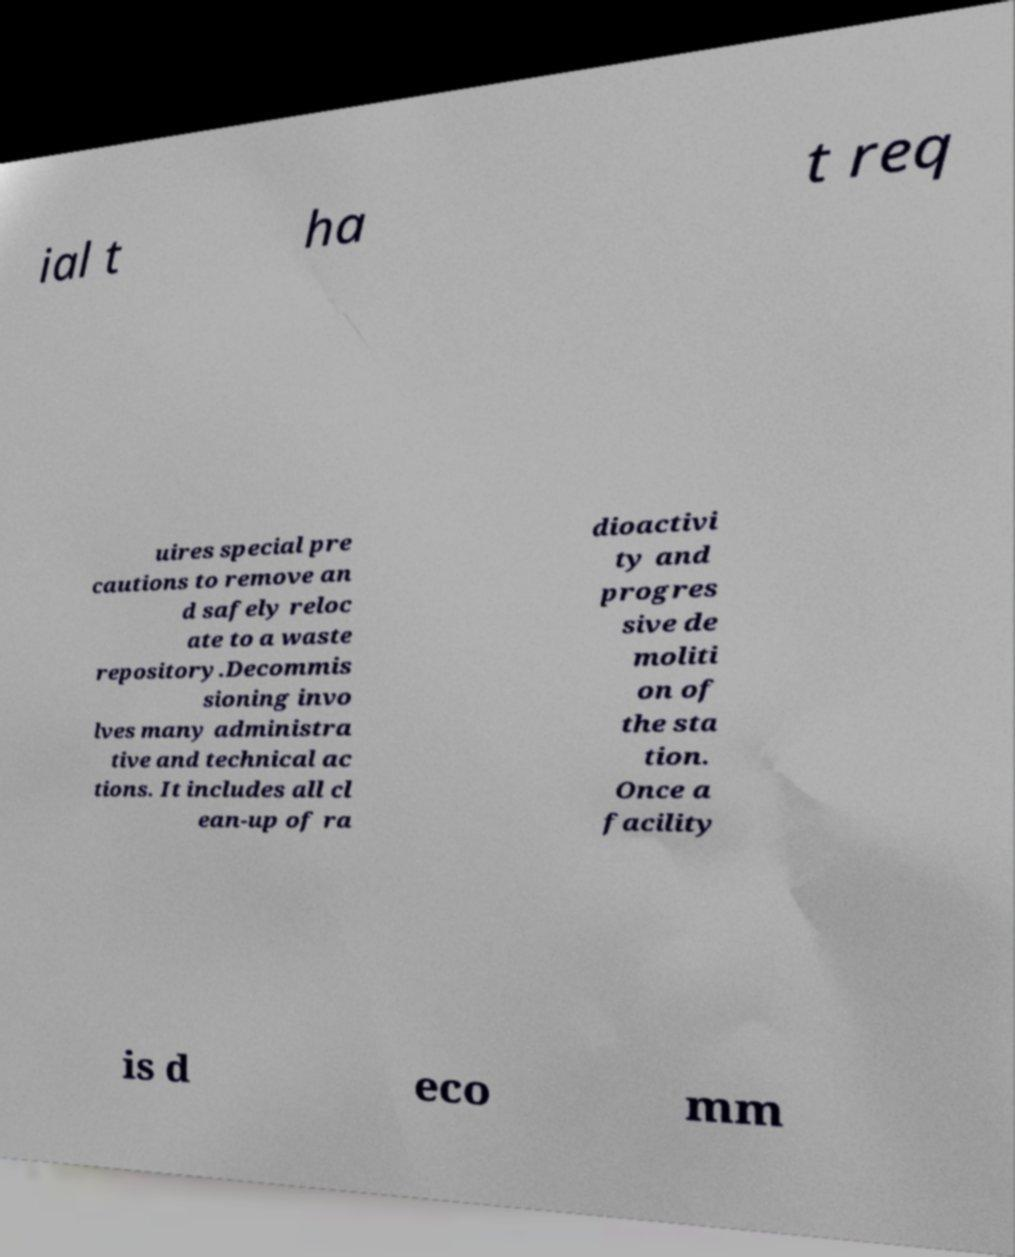There's text embedded in this image that I need extracted. Can you transcribe it verbatim? ial t ha t req uires special pre cautions to remove an d safely reloc ate to a waste repository.Decommis sioning invo lves many administra tive and technical ac tions. It includes all cl ean-up of ra dioactivi ty and progres sive de moliti on of the sta tion. Once a facility is d eco mm 